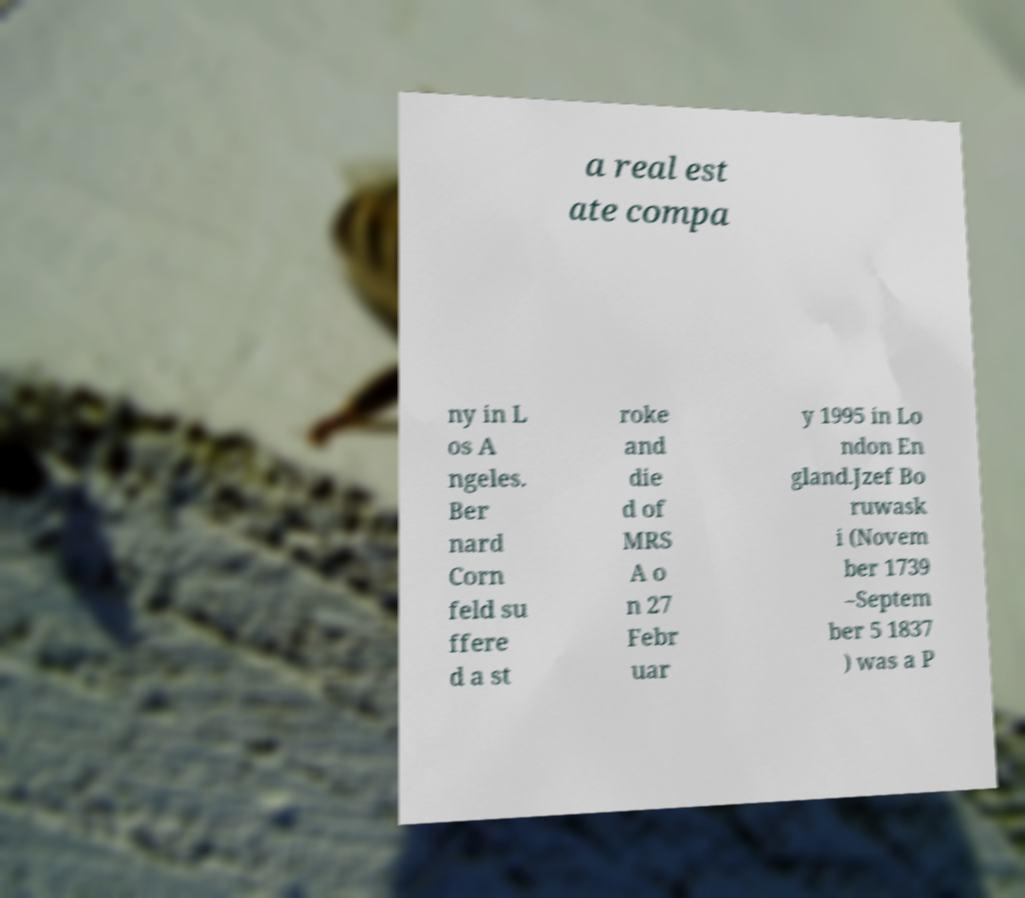There's text embedded in this image that I need extracted. Can you transcribe it verbatim? a real est ate compa ny in L os A ngeles. Ber nard Corn feld su ffere d a st roke and die d of MRS A o n 27 Febr uar y 1995 in Lo ndon En gland.Jzef Bo ruwask i (Novem ber 1739 –Septem ber 5 1837 ) was a P 